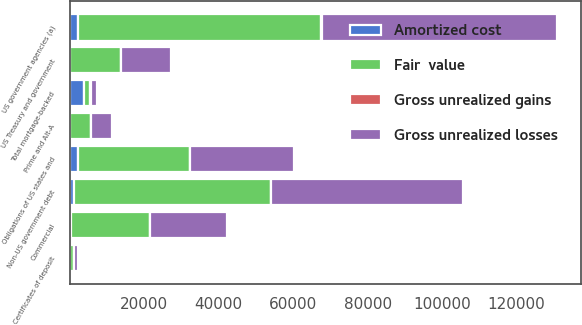Convert chart. <chart><loc_0><loc_0><loc_500><loc_500><stacked_bar_chart><ecel><fcel>US government agencies (a)<fcel>Prime and Alt-A<fcel>Commercial<fcel>Total mortgage-backed<fcel>US Treasury and government<fcel>Obligations of US states and<fcel>Certificates of deposit<fcel>Non-US government debt<nl><fcel>Gross unrealized losses<fcel>63089<fcel>5595<fcel>20687<fcel>1757.5<fcel>13603<fcel>27841<fcel>1103<fcel>51492<nl><fcel>Amortized cost<fcel>2302<fcel>78<fcel>438<fcel>3842<fcel>56<fcel>2243<fcel>1<fcel>1272<nl><fcel>Gross unrealized gains<fcel>72<fcel>29<fcel>17<fcel>118<fcel>14<fcel>16<fcel>1<fcel>21<nl><fcel>Fair  value<fcel>65319<fcel>5644<fcel>21108<fcel>1757.5<fcel>13645<fcel>30068<fcel>1103<fcel>52743<nl></chart> 